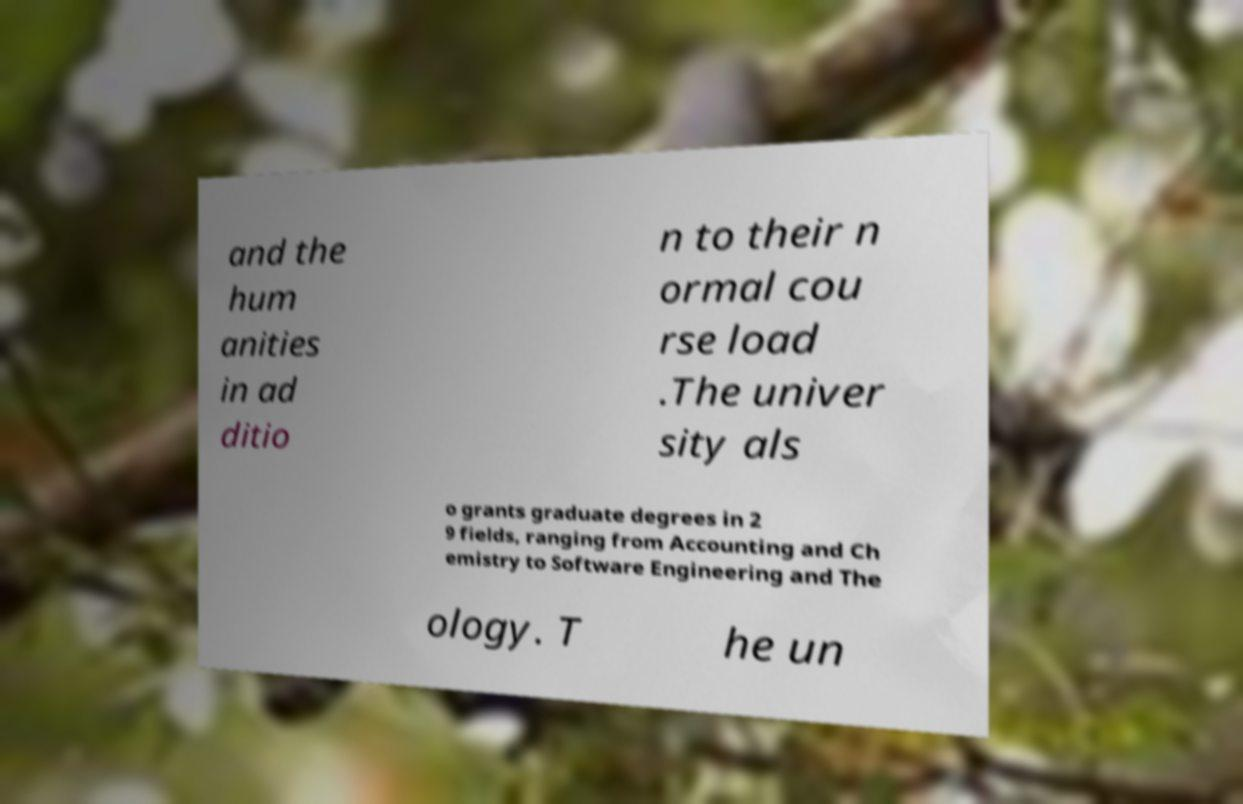Could you assist in decoding the text presented in this image and type it out clearly? and the hum anities in ad ditio n to their n ormal cou rse load .The univer sity als o grants graduate degrees in 2 9 fields, ranging from Accounting and Ch emistry to Software Engineering and The ology. T he un 